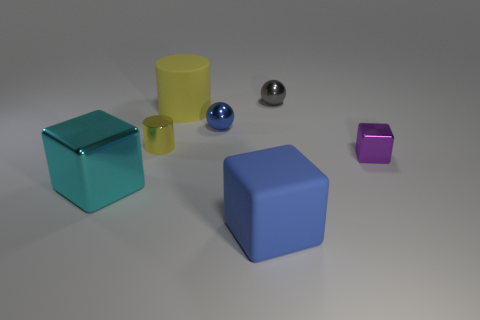Subtract all cyan metal blocks. How many blocks are left? 2 Add 2 cyan blocks. How many objects exist? 9 Subtract 0 brown spheres. How many objects are left? 7 Subtract all spheres. How many objects are left? 5 Subtract all gray cylinders. Subtract all red cubes. How many cylinders are left? 2 Subtract all small brown cubes. Subtract all yellow cylinders. How many objects are left? 5 Add 1 blue metal balls. How many blue metal balls are left? 2 Add 5 big cyan cubes. How many big cyan cubes exist? 6 